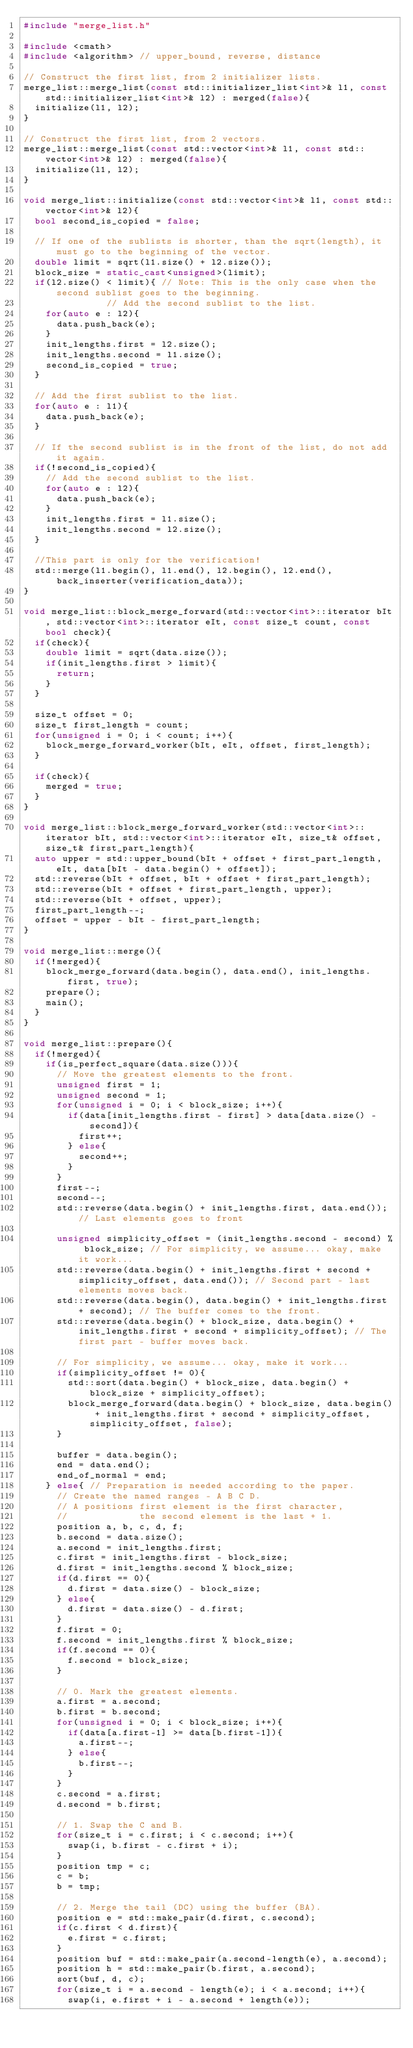Convert code to text. <code><loc_0><loc_0><loc_500><loc_500><_C++_>#include "merge_list.h"

#include <cmath>
#include <algorithm> // upper_bound, reverse, distance

// Construct the first list, from 2 initializer lists.
merge_list::merge_list(const std::initializer_list<int>& l1, const std::initializer_list<int>& l2) : merged(false){
	initialize(l1, l2);
}

// Construct the first list, from 2 vectors.
merge_list::merge_list(const std::vector<int>& l1, const std::vector<int>& l2) : merged(false){
	initialize(l1, l2);
}

void merge_list::initialize(const std::vector<int>& l1, const std::vector<int>& l2){
	bool second_is_copied = false;

	// If one of the sublists is shorter, than the sqrt(length), it must go to the beginning of the vector.
	double limit = sqrt(l1.size() + l2.size());
	block_size = static_cast<unsigned>(limit);
	if(l2.size() < limit){ // Note: This is the only case when the second sublist goes to the beginning.
						   // Add the second sublist to the list.
		for(auto e : l2){
			data.push_back(e);
		}
		init_lengths.first = l2.size();
		init_lengths.second = l1.size();
		second_is_copied = true;
	}

	// Add the first sublist to the list.
	for(auto e : l1){
		data.push_back(e);
	}

	// If the second sublist is in the front of the list, do not add it again.
	if(!second_is_copied){
		// Add the second sublist to the list.
		for(auto e : l2){
			data.push_back(e);
		}
		init_lengths.first = l1.size();
		init_lengths.second = l2.size();
	}

	//This part is only for the verification!
	std::merge(l1.begin(), l1.end(), l2.begin(), l2.end(), back_inserter(verification_data));
}

void merge_list::block_merge_forward(std::vector<int>::iterator bIt, std::vector<int>::iterator eIt, const size_t count, const bool check){
	if(check){ 
		double limit = sqrt(data.size());
		if(init_lengths.first > limit){
			return;
		}
	}

	size_t offset = 0;
	size_t first_length = count;
	for(unsigned i = 0; i < count; i++){
		block_merge_forward_worker(bIt, eIt, offset, first_length);
	}

	if(check){
		merged = true;
	}
}

void merge_list::block_merge_forward_worker(std::vector<int>::iterator bIt, std::vector<int>::iterator eIt, size_t& offset, size_t& first_part_length){
	auto upper = std::upper_bound(bIt + offset + first_part_length, eIt, data[bIt - data.begin() + offset]);
	std::reverse(bIt + offset, bIt + offset + first_part_length);
	std::reverse(bIt + offset + first_part_length, upper);
	std::reverse(bIt + offset, upper);
	first_part_length--; 
	offset = upper - bIt - first_part_length;
}

void merge_list::merge(){
	if(!merged){
		block_merge_forward(data.begin(), data.end(), init_lengths.first, true);
		prepare();
		main();
	}
}

void merge_list::prepare(){
	if(!merged){
		if(is_perfect_square(data.size())){
			// Move the greatest elements to the front.
			unsigned first = 1;
			unsigned second = 1;
			for(unsigned i = 0; i < block_size; i++){
				if(data[init_lengths.first - first] > data[data.size() - second]){
					first++;
				} else{
					second++;
				}
			}
			first--;
			second--;
			std::reverse(data.begin() + init_lengths.first, data.end()); // Last elements goes to front

			unsigned simplicity_offset = (init_lengths.second - second) % block_size; // For simplicity, we assume... okay, make it work...
			std::reverse(data.begin() + init_lengths.first + second + simplicity_offset, data.end()); // Second part - last elements moves back.
			std::reverse(data.begin(), data.begin() + init_lengths.first + second); // The buffer comes to the front.
			std::reverse(data.begin() + block_size, data.begin() + init_lengths.first + second + simplicity_offset); // The first part - buffer moves back.

			// For simplicity, we assume... okay, make it work...
			if(simplicity_offset != 0){
				std::sort(data.begin() + block_size, data.begin() + block_size + simplicity_offset);
				block_merge_forward(data.begin() + block_size, data.begin() + init_lengths.first + second + simplicity_offset, simplicity_offset, false);
			}

			buffer = data.begin();
			end = data.end();
			end_of_normal = end;
		} else{ // Preparation is needed according to the paper.
			// Create the named ranges - A B C D.
			// A positions first element is the first character,
			//             the second element is the last + 1.
			position a, b, c, d, f;
			b.second = data.size();
			a.second = init_lengths.first;
			c.first = init_lengths.first - block_size;
			d.first = init_lengths.second % block_size;
			if(d.first == 0){
				d.first = data.size() - block_size;
			} else{
				d.first = data.size() - d.first;
			}
			f.first = 0;
			f.second = init_lengths.first % block_size;
			if(f.second == 0){
				f.second = block_size;
			}

			// 0. Mark the greatest elements.
			a.first = a.second;
			b.first = b.second;
			for(unsigned i = 0; i < block_size; i++){
				if(data[a.first-1] >= data[b.first-1]){
					a.first--;
				} else{
					b.first--;
				}
			}
			c.second = a.first;
			d.second = b.first;

			// 1. Swap the C and B.
			for(size_t i = c.first; i < c.second; i++){
				swap(i, b.first - c.first + i);
			}
			position tmp = c;
			c = b;
			b = tmp;

			// 2. Merge the tail (DC) using the buffer (BA).
			position e = std::make_pair(d.first, c.second);
			if(c.first < d.first){
				e.first = c.first;
			}
			position buf = std::make_pair(a.second-length(e), a.second);
			position h = std::make_pair(b.first, a.second);
			sort(buf, d, c);
			for(size_t i = a.second - length(e); i < a.second; i++){
				swap(i, e.first + i - a.second + length(e));</code> 